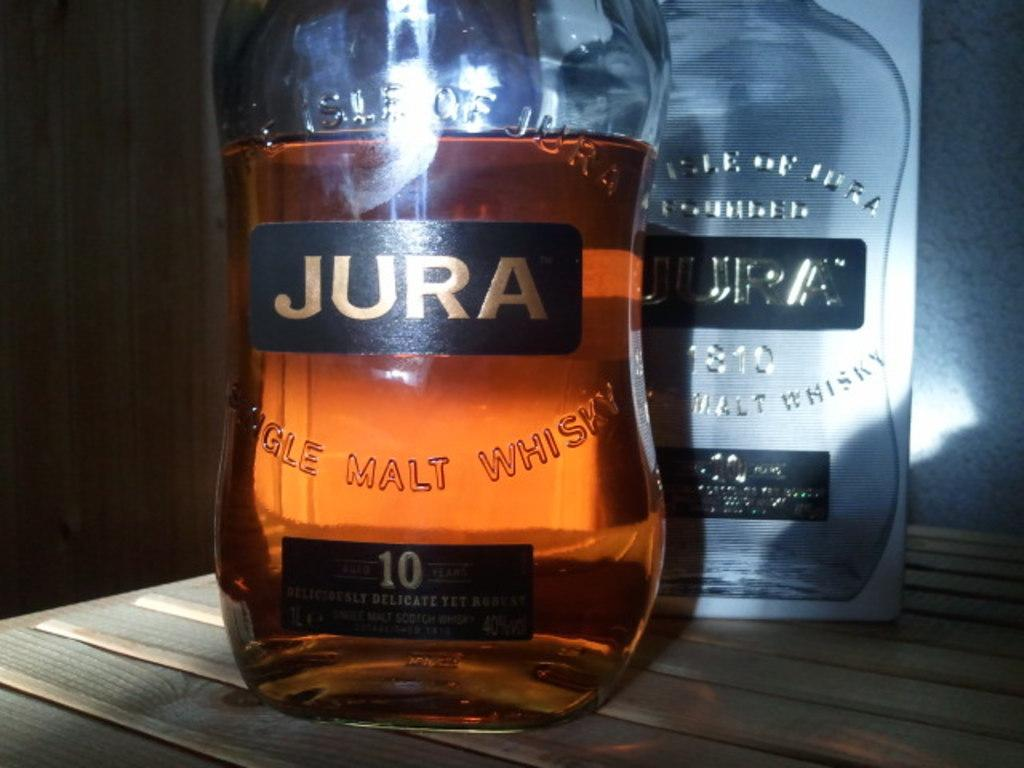Provide a one-sentence caption for the provided image. A partially full bottle of Jura whisky in front of an empty one. 